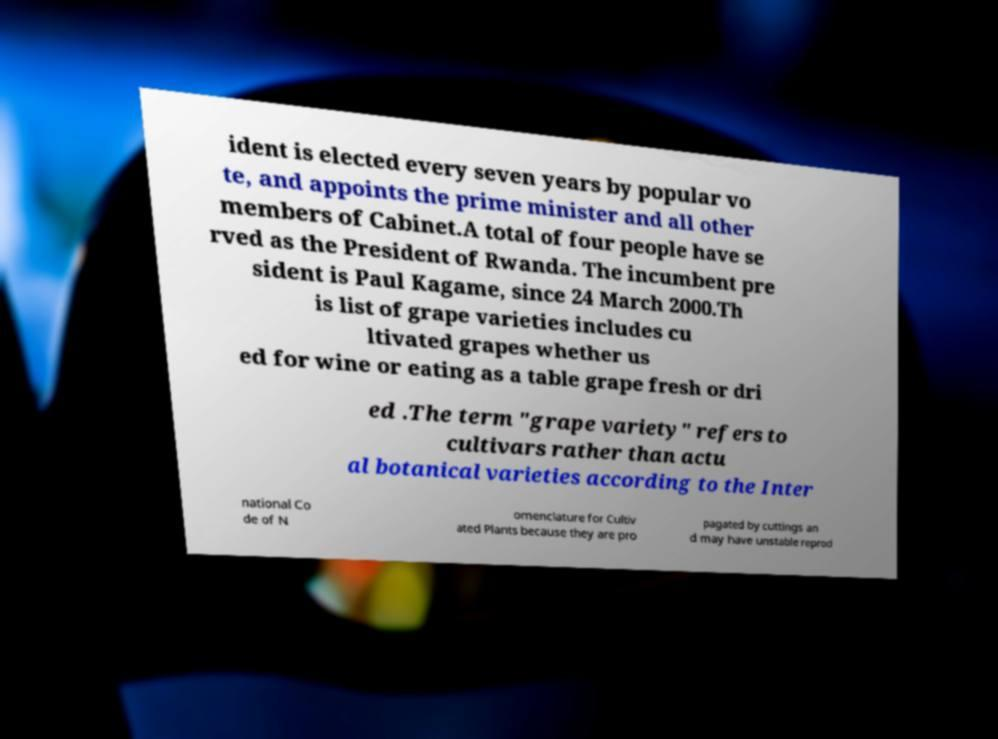Could you extract and type out the text from this image? ident is elected every seven years by popular vo te, and appoints the prime minister and all other members of Cabinet.A total of four people have se rved as the President of Rwanda. The incumbent pre sident is Paul Kagame, since 24 March 2000.Th is list of grape varieties includes cu ltivated grapes whether us ed for wine or eating as a table grape fresh or dri ed .The term "grape variety" refers to cultivars rather than actu al botanical varieties according to the Inter national Co de of N omenclature for Cultiv ated Plants because they are pro pagated by cuttings an d may have unstable reprod 